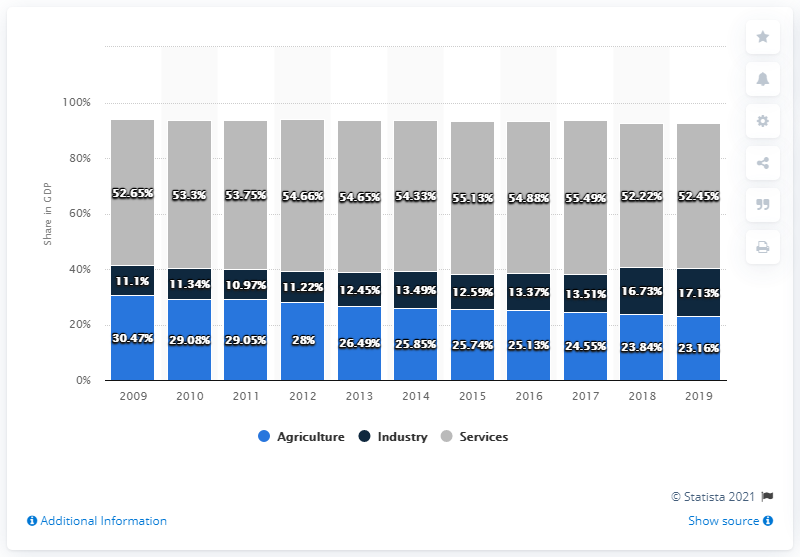Indicate a few pertinent items in this graphic. In 2016, the share of agriculture in Madagascar's GDP was 25.13%. In 2011, the difference between the GDP of Madagascar's services and industry sectors was the highest on record. 